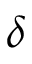Convert formula to latex. <formula><loc_0><loc_0><loc_500><loc_500>\delta</formula> 